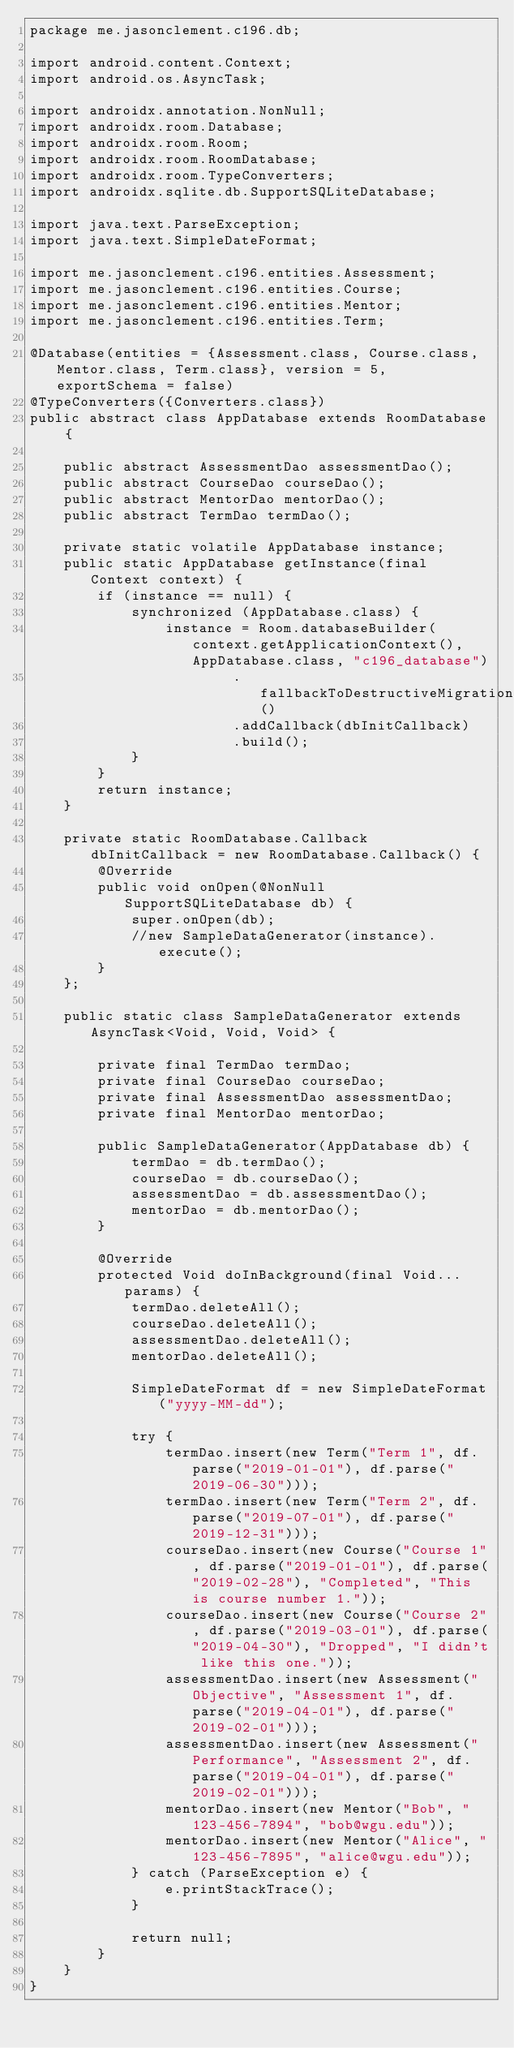<code> <loc_0><loc_0><loc_500><loc_500><_Java_>package me.jasonclement.c196.db;

import android.content.Context;
import android.os.AsyncTask;

import androidx.annotation.NonNull;
import androidx.room.Database;
import androidx.room.Room;
import androidx.room.RoomDatabase;
import androidx.room.TypeConverters;
import androidx.sqlite.db.SupportSQLiteDatabase;

import java.text.ParseException;
import java.text.SimpleDateFormat;

import me.jasonclement.c196.entities.Assessment;
import me.jasonclement.c196.entities.Course;
import me.jasonclement.c196.entities.Mentor;
import me.jasonclement.c196.entities.Term;

@Database(entities = {Assessment.class, Course.class, Mentor.class, Term.class}, version = 5, exportSchema = false)
@TypeConverters({Converters.class})
public abstract class AppDatabase extends RoomDatabase {

    public abstract AssessmentDao assessmentDao();
    public abstract CourseDao courseDao();
    public abstract MentorDao mentorDao();
    public abstract TermDao termDao();

    private static volatile AppDatabase instance;
    public static AppDatabase getInstance(final Context context) {
        if (instance == null) {
            synchronized (AppDatabase.class) {
                instance = Room.databaseBuilder(context.getApplicationContext(), AppDatabase.class, "c196_database")
                        .fallbackToDestructiveMigration()
                        .addCallback(dbInitCallback)
                        .build();
            }
        }
        return instance;
    }

    private static RoomDatabase.Callback dbInitCallback = new RoomDatabase.Callback() {
        @Override
        public void onOpen(@NonNull SupportSQLiteDatabase db) {
            super.onOpen(db);
            //new SampleDataGenerator(instance).execute();
        }
    };

    public static class SampleDataGenerator extends AsyncTask<Void, Void, Void> {

        private final TermDao termDao;
        private final CourseDao courseDao;
        private final AssessmentDao assessmentDao;
        private final MentorDao mentorDao;

        public SampleDataGenerator(AppDatabase db) {
            termDao = db.termDao();
            courseDao = db.courseDao();
            assessmentDao = db.assessmentDao();
            mentorDao = db.mentorDao();
        }

        @Override
        protected Void doInBackground(final Void... params) {
            termDao.deleteAll();
            courseDao.deleteAll();
            assessmentDao.deleteAll();
            mentorDao.deleteAll();

            SimpleDateFormat df = new SimpleDateFormat("yyyy-MM-dd");

            try {
                termDao.insert(new Term("Term 1", df.parse("2019-01-01"), df.parse("2019-06-30")));
                termDao.insert(new Term("Term 2", df.parse("2019-07-01"), df.parse("2019-12-31")));
                courseDao.insert(new Course("Course 1", df.parse("2019-01-01"), df.parse("2019-02-28"), "Completed", "This is course number 1."));
                courseDao.insert(new Course("Course 2", df.parse("2019-03-01"), df.parse("2019-04-30"), "Dropped", "I didn't like this one."));
                assessmentDao.insert(new Assessment("Objective", "Assessment 1", df.parse("2019-04-01"), df.parse("2019-02-01")));
                assessmentDao.insert(new Assessment("Performance", "Assessment 2", df.parse("2019-04-01"), df.parse("2019-02-01")));
                mentorDao.insert(new Mentor("Bob", "123-456-7894", "bob@wgu.edu"));
                mentorDao.insert(new Mentor("Alice", "123-456-7895", "alice@wgu.edu"));
            } catch (ParseException e) {
                e.printStackTrace();
            }

            return null;
        }
    }
}
</code> 